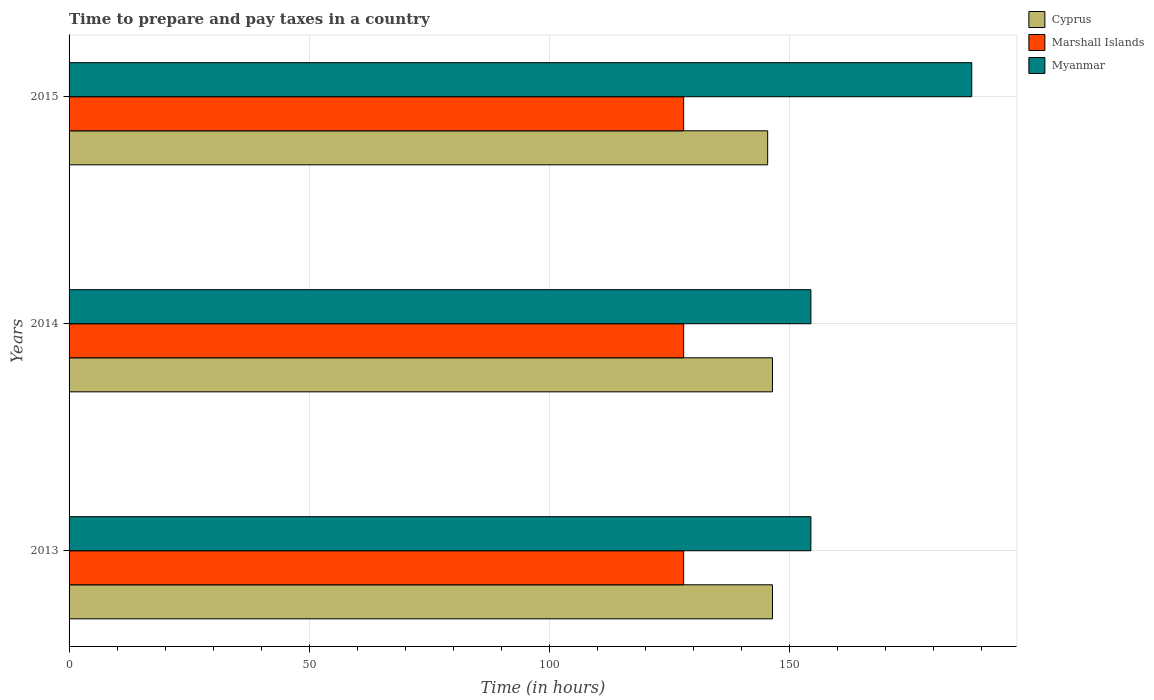How many groups of bars are there?
Keep it short and to the point. 3. Are the number of bars per tick equal to the number of legend labels?
Give a very brief answer. Yes. Are the number of bars on each tick of the Y-axis equal?
Ensure brevity in your answer.  Yes. How many bars are there on the 2nd tick from the top?
Keep it short and to the point. 3. How many bars are there on the 1st tick from the bottom?
Your response must be concise. 3. What is the number of hours required to prepare and pay taxes in Myanmar in 2014?
Your answer should be compact. 154.5. Across all years, what is the maximum number of hours required to prepare and pay taxes in Myanmar?
Provide a succinct answer. 188. Across all years, what is the minimum number of hours required to prepare and pay taxes in Cyprus?
Offer a terse response. 145.5. In which year was the number of hours required to prepare and pay taxes in Marshall Islands minimum?
Keep it short and to the point. 2013. What is the total number of hours required to prepare and pay taxes in Myanmar in the graph?
Your answer should be very brief. 497. What is the difference between the number of hours required to prepare and pay taxes in Marshall Islands in 2013 and the number of hours required to prepare and pay taxes in Myanmar in 2015?
Give a very brief answer. -60. What is the average number of hours required to prepare and pay taxes in Cyprus per year?
Your answer should be compact. 146.17. In how many years, is the number of hours required to prepare and pay taxes in Marshall Islands greater than 140 hours?
Provide a short and direct response. 0. Is the difference between the number of hours required to prepare and pay taxes in Cyprus in 2013 and 2015 greater than the difference between the number of hours required to prepare and pay taxes in Marshall Islands in 2013 and 2015?
Your response must be concise. Yes. What is the difference between the highest and the lowest number of hours required to prepare and pay taxes in Myanmar?
Make the answer very short. 33.5. What does the 3rd bar from the top in 2014 represents?
Make the answer very short. Cyprus. What does the 2nd bar from the bottom in 2013 represents?
Your answer should be very brief. Marshall Islands. Is it the case that in every year, the sum of the number of hours required to prepare and pay taxes in Cyprus and number of hours required to prepare and pay taxes in Marshall Islands is greater than the number of hours required to prepare and pay taxes in Myanmar?
Offer a very short reply. Yes. Are all the bars in the graph horizontal?
Your answer should be compact. Yes. Does the graph contain grids?
Offer a very short reply. Yes. What is the title of the graph?
Provide a succinct answer. Time to prepare and pay taxes in a country. What is the label or title of the X-axis?
Your answer should be very brief. Time (in hours). What is the label or title of the Y-axis?
Your response must be concise. Years. What is the Time (in hours) in Cyprus in 2013?
Your response must be concise. 146.5. What is the Time (in hours) of Marshall Islands in 2013?
Make the answer very short. 128. What is the Time (in hours) of Myanmar in 2013?
Your response must be concise. 154.5. What is the Time (in hours) in Cyprus in 2014?
Offer a very short reply. 146.5. What is the Time (in hours) in Marshall Islands in 2014?
Provide a short and direct response. 128. What is the Time (in hours) of Myanmar in 2014?
Make the answer very short. 154.5. What is the Time (in hours) of Cyprus in 2015?
Your answer should be very brief. 145.5. What is the Time (in hours) of Marshall Islands in 2015?
Ensure brevity in your answer.  128. What is the Time (in hours) in Myanmar in 2015?
Your response must be concise. 188. Across all years, what is the maximum Time (in hours) of Cyprus?
Ensure brevity in your answer.  146.5. Across all years, what is the maximum Time (in hours) of Marshall Islands?
Ensure brevity in your answer.  128. Across all years, what is the maximum Time (in hours) of Myanmar?
Give a very brief answer. 188. Across all years, what is the minimum Time (in hours) in Cyprus?
Keep it short and to the point. 145.5. Across all years, what is the minimum Time (in hours) in Marshall Islands?
Make the answer very short. 128. Across all years, what is the minimum Time (in hours) of Myanmar?
Offer a very short reply. 154.5. What is the total Time (in hours) in Cyprus in the graph?
Make the answer very short. 438.5. What is the total Time (in hours) of Marshall Islands in the graph?
Offer a terse response. 384. What is the total Time (in hours) in Myanmar in the graph?
Keep it short and to the point. 497. What is the difference between the Time (in hours) in Marshall Islands in 2013 and that in 2014?
Keep it short and to the point. 0. What is the difference between the Time (in hours) of Myanmar in 2013 and that in 2015?
Provide a succinct answer. -33.5. What is the difference between the Time (in hours) in Myanmar in 2014 and that in 2015?
Give a very brief answer. -33.5. What is the difference between the Time (in hours) in Cyprus in 2013 and the Time (in hours) in Myanmar in 2014?
Make the answer very short. -8. What is the difference between the Time (in hours) of Marshall Islands in 2013 and the Time (in hours) of Myanmar in 2014?
Keep it short and to the point. -26.5. What is the difference between the Time (in hours) of Cyprus in 2013 and the Time (in hours) of Marshall Islands in 2015?
Keep it short and to the point. 18.5. What is the difference between the Time (in hours) of Cyprus in 2013 and the Time (in hours) of Myanmar in 2015?
Provide a succinct answer. -41.5. What is the difference between the Time (in hours) in Marshall Islands in 2013 and the Time (in hours) in Myanmar in 2015?
Offer a terse response. -60. What is the difference between the Time (in hours) in Cyprus in 2014 and the Time (in hours) in Marshall Islands in 2015?
Provide a short and direct response. 18.5. What is the difference between the Time (in hours) in Cyprus in 2014 and the Time (in hours) in Myanmar in 2015?
Provide a short and direct response. -41.5. What is the difference between the Time (in hours) of Marshall Islands in 2014 and the Time (in hours) of Myanmar in 2015?
Offer a terse response. -60. What is the average Time (in hours) of Cyprus per year?
Ensure brevity in your answer.  146.17. What is the average Time (in hours) in Marshall Islands per year?
Offer a very short reply. 128. What is the average Time (in hours) of Myanmar per year?
Provide a succinct answer. 165.67. In the year 2013, what is the difference between the Time (in hours) of Cyprus and Time (in hours) of Myanmar?
Ensure brevity in your answer.  -8. In the year 2013, what is the difference between the Time (in hours) of Marshall Islands and Time (in hours) of Myanmar?
Provide a succinct answer. -26.5. In the year 2014, what is the difference between the Time (in hours) of Cyprus and Time (in hours) of Myanmar?
Give a very brief answer. -8. In the year 2014, what is the difference between the Time (in hours) of Marshall Islands and Time (in hours) of Myanmar?
Offer a very short reply. -26.5. In the year 2015, what is the difference between the Time (in hours) of Cyprus and Time (in hours) of Marshall Islands?
Ensure brevity in your answer.  17.5. In the year 2015, what is the difference between the Time (in hours) in Cyprus and Time (in hours) in Myanmar?
Offer a terse response. -42.5. In the year 2015, what is the difference between the Time (in hours) of Marshall Islands and Time (in hours) of Myanmar?
Your response must be concise. -60. What is the ratio of the Time (in hours) of Cyprus in 2013 to that in 2014?
Make the answer very short. 1. What is the ratio of the Time (in hours) of Marshall Islands in 2013 to that in 2014?
Make the answer very short. 1. What is the ratio of the Time (in hours) of Cyprus in 2013 to that in 2015?
Keep it short and to the point. 1.01. What is the ratio of the Time (in hours) in Myanmar in 2013 to that in 2015?
Your answer should be compact. 0.82. What is the ratio of the Time (in hours) of Marshall Islands in 2014 to that in 2015?
Ensure brevity in your answer.  1. What is the ratio of the Time (in hours) of Myanmar in 2014 to that in 2015?
Offer a very short reply. 0.82. What is the difference between the highest and the second highest Time (in hours) in Myanmar?
Your response must be concise. 33.5. What is the difference between the highest and the lowest Time (in hours) of Marshall Islands?
Ensure brevity in your answer.  0. What is the difference between the highest and the lowest Time (in hours) of Myanmar?
Keep it short and to the point. 33.5. 